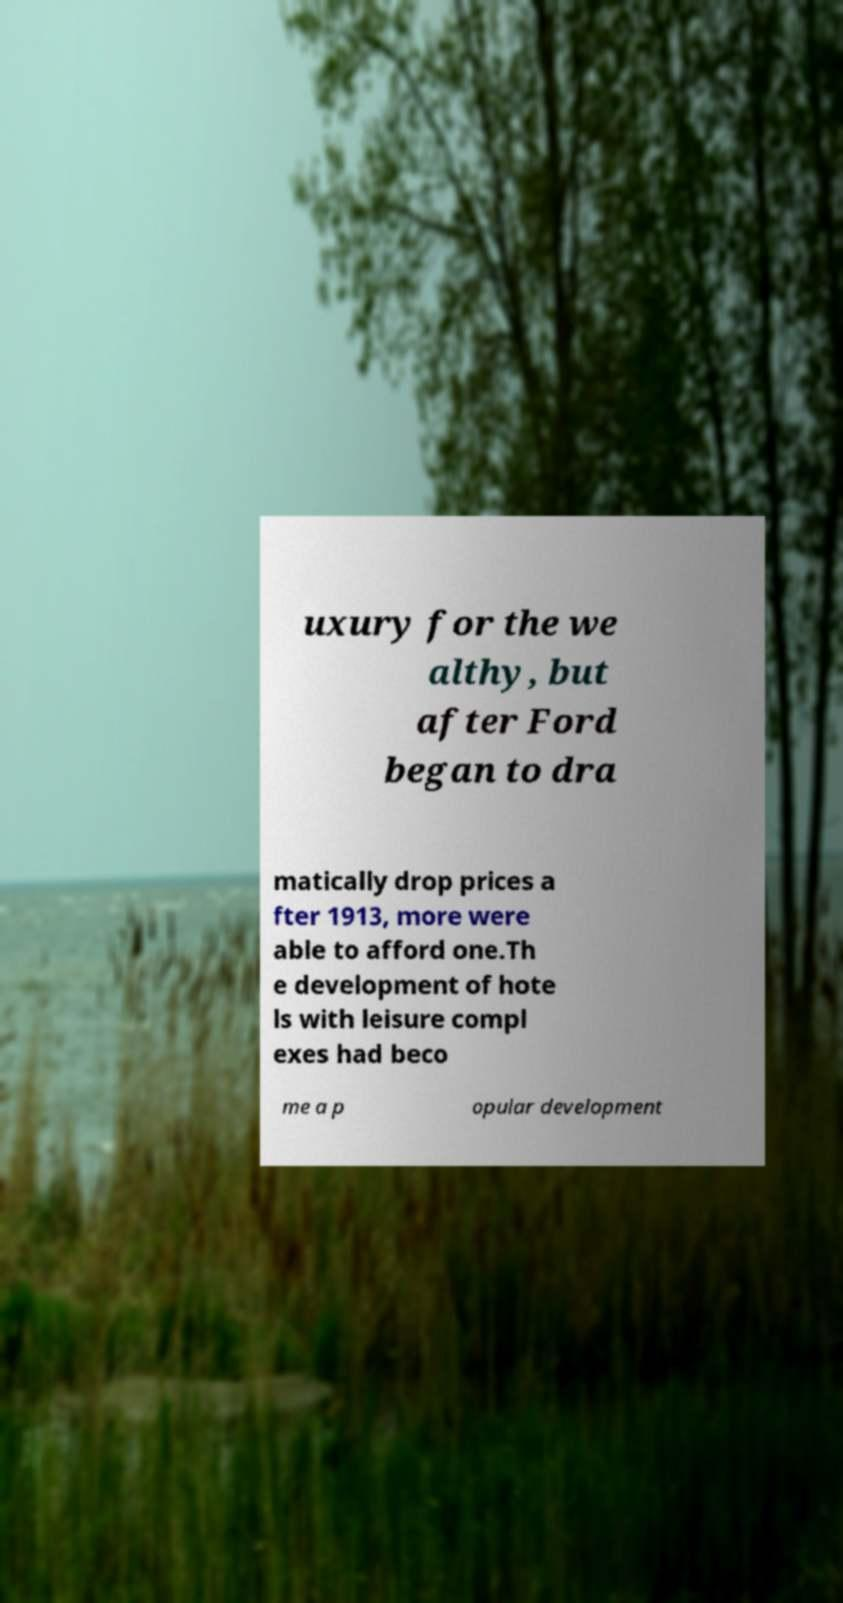Can you accurately transcribe the text from the provided image for me? uxury for the we althy, but after Ford began to dra matically drop prices a fter 1913, more were able to afford one.Th e development of hote ls with leisure compl exes had beco me a p opular development 